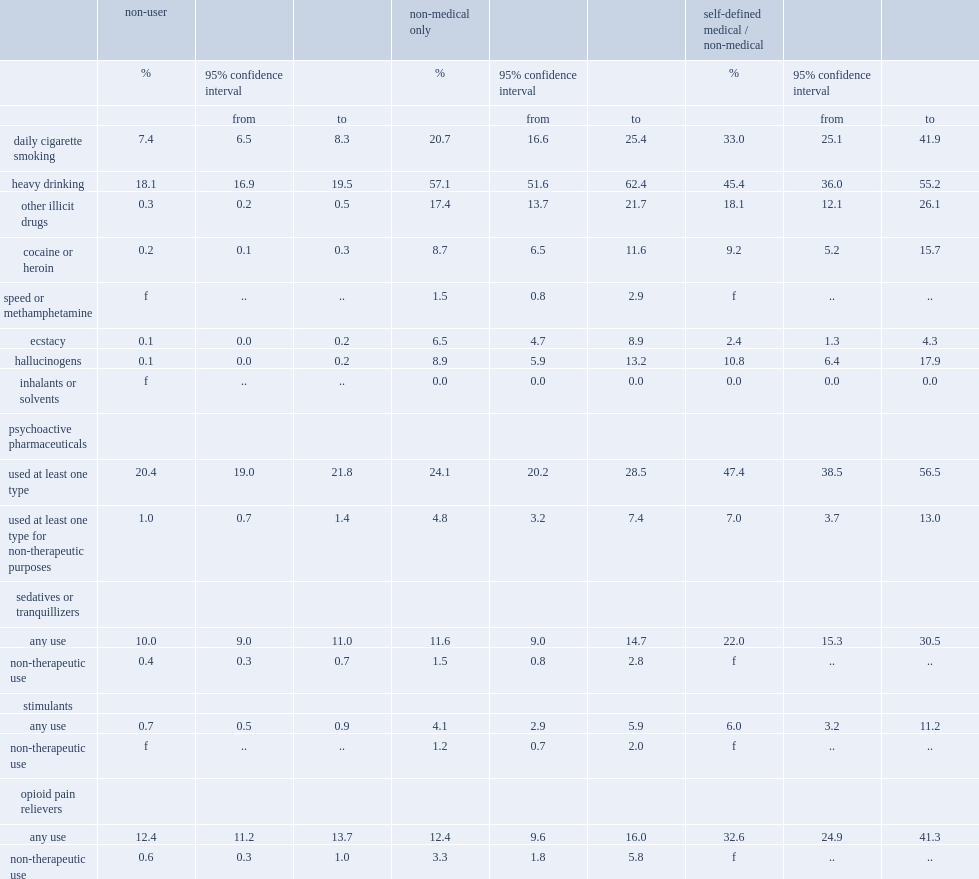What was the percentage of nmo and sdmnm past-year cannabis users who reported using other illicit drugs respectively? 17.4 18.1. What was the percentage of sdmnm cannabis users who reported using at least one psychoactive medication? 47.4. Who were least likely to admit using these medications for reasons other than the prescribed therapeutic purposes,nmo,sdmnm cannabis users or those who do not use cannabis? Non-user. Who were least likely to report daily cigarette smoking? Non-user. 